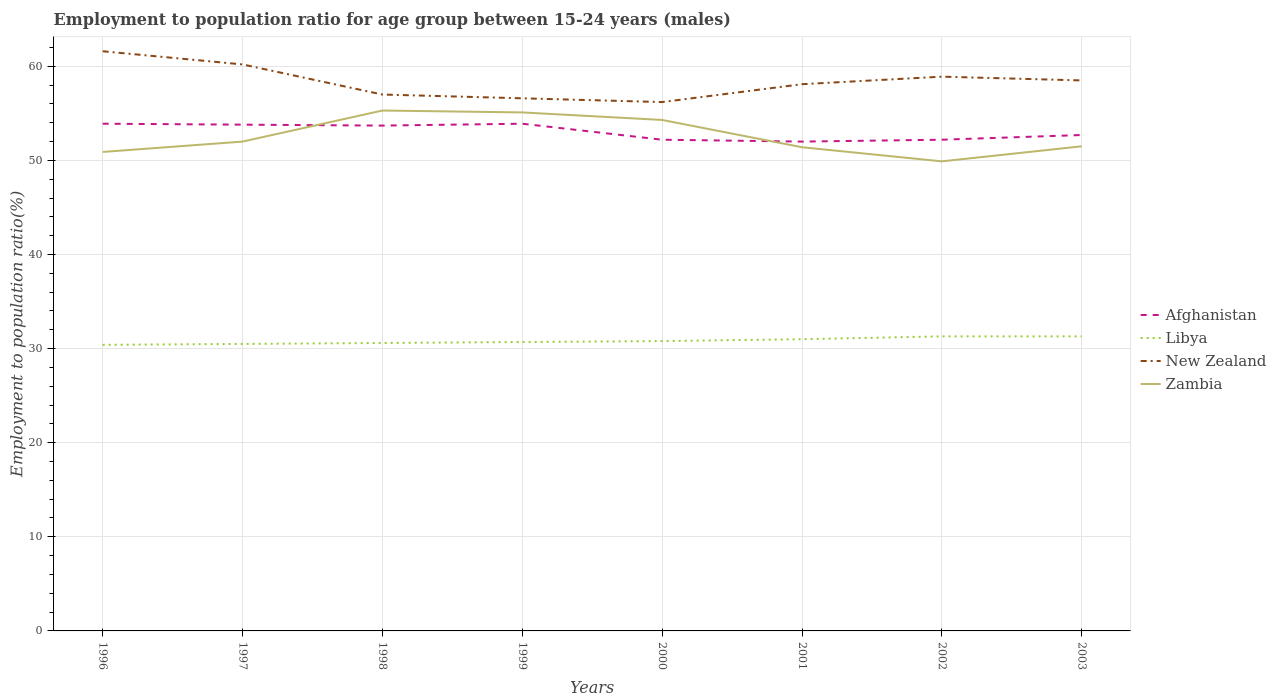How many different coloured lines are there?
Give a very brief answer. 4. Is the number of lines equal to the number of legend labels?
Give a very brief answer. Yes. Across all years, what is the maximum employment to population ratio in Afghanistan?
Provide a succinct answer. 52. What is the total employment to population ratio in Afghanistan in the graph?
Your response must be concise. -0.7. What is the difference between the highest and the second highest employment to population ratio in Afghanistan?
Offer a very short reply. 1.9. Are the values on the major ticks of Y-axis written in scientific E-notation?
Offer a terse response. No. Does the graph contain any zero values?
Provide a succinct answer. No. Where does the legend appear in the graph?
Provide a short and direct response. Center right. How are the legend labels stacked?
Your answer should be compact. Vertical. What is the title of the graph?
Ensure brevity in your answer.  Employment to population ratio for age group between 15-24 years (males). Does "Mexico" appear as one of the legend labels in the graph?
Your answer should be compact. No. What is the label or title of the X-axis?
Provide a short and direct response. Years. What is the label or title of the Y-axis?
Provide a succinct answer. Employment to population ratio(%). What is the Employment to population ratio(%) in Afghanistan in 1996?
Ensure brevity in your answer.  53.9. What is the Employment to population ratio(%) in Libya in 1996?
Ensure brevity in your answer.  30.4. What is the Employment to population ratio(%) of New Zealand in 1996?
Give a very brief answer. 61.6. What is the Employment to population ratio(%) of Zambia in 1996?
Ensure brevity in your answer.  50.9. What is the Employment to population ratio(%) of Afghanistan in 1997?
Keep it short and to the point. 53.8. What is the Employment to population ratio(%) of Libya in 1997?
Offer a very short reply. 30.5. What is the Employment to population ratio(%) in New Zealand in 1997?
Ensure brevity in your answer.  60.2. What is the Employment to population ratio(%) in Afghanistan in 1998?
Your answer should be very brief. 53.7. What is the Employment to population ratio(%) in Libya in 1998?
Keep it short and to the point. 30.6. What is the Employment to population ratio(%) in Zambia in 1998?
Keep it short and to the point. 55.3. What is the Employment to population ratio(%) in Afghanistan in 1999?
Offer a very short reply. 53.9. What is the Employment to population ratio(%) in Libya in 1999?
Provide a short and direct response. 30.7. What is the Employment to population ratio(%) in New Zealand in 1999?
Your answer should be compact. 56.6. What is the Employment to population ratio(%) of Zambia in 1999?
Your answer should be very brief. 55.1. What is the Employment to population ratio(%) in Afghanistan in 2000?
Ensure brevity in your answer.  52.2. What is the Employment to population ratio(%) in Libya in 2000?
Provide a short and direct response. 30.8. What is the Employment to population ratio(%) in New Zealand in 2000?
Offer a very short reply. 56.2. What is the Employment to population ratio(%) in Zambia in 2000?
Provide a succinct answer. 54.3. What is the Employment to population ratio(%) of Afghanistan in 2001?
Keep it short and to the point. 52. What is the Employment to population ratio(%) in Libya in 2001?
Keep it short and to the point. 31. What is the Employment to population ratio(%) in New Zealand in 2001?
Keep it short and to the point. 58.1. What is the Employment to population ratio(%) in Zambia in 2001?
Keep it short and to the point. 51.4. What is the Employment to population ratio(%) in Afghanistan in 2002?
Your response must be concise. 52.2. What is the Employment to population ratio(%) in Libya in 2002?
Offer a terse response. 31.3. What is the Employment to population ratio(%) in New Zealand in 2002?
Make the answer very short. 58.9. What is the Employment to population ratio(%) in Zambia in 2002?
Your answer should be compact. 49.9. What is the Employment to population ratio(%) of Afghanistan in 2003?
Keep it short and to the point. 52.7. What is the Employment to population ratio(%) of Libya in 2003?
Give a very brief answer. 31.3. What is the Employment to population ratio(%) of New Zealand in 2003?
Your answer should be very brief. 58.5. What is the Employment to population ratio(%) in Zambia in 2003?
Your response must be concise. 51.5. Across all years, what is the maximum Employment to population ratio(%) in Afghanistan?
Ensure brevity in your answer.  53.9. Across all years, what is the maximum Employment to population ratio(%) of Libya?
Your answer should be compact. 31.3. Across all years, what is the maximum Employment to population ratio(%) in New Zealand?
Your answer should be compact. 61.6. Across all years, what is the maximum Employment to population ratio(%) of Zambia?
Offer a terse response. 55.3. Across all years, what is the minimum Employment to population ratio(%) in Libya?
Your answer should be compact. 30.4. Across all years, what is the minimum Employment to population ratio(%) of New Zealand?
Offer a very short reply. 56.2. Across all years, what is the minimum Employment to population ratio(%) in Zambia?
Offer a terse response. 49.9. What is the total Employment to population ratio(%) in Afghanistan in the graph?
Make the answer very short. 424.4. What is the total Employment to population ratio(%) in Libya in the graph?
Give a very brief answer. 246.6. What is the total Employment to population ratio(%) of New Zealand in the graph?
Your response must be concise. 467.1. What is the total Employment to population ratio(%) of Zambia in the graph?
Provide a short and direct response. 420.4. What is the difference between the Employment to population ratio(%) in Zambia in 1996 and that in 1997?
Your answer should be compact. -1.1. What is the difference between the Employment to population ratio(%) of New Zealand in 1996 and that in 1999?
Offer a terse response. 5. What is the difference between the Employment to population ratio(%) of Zambia in 1996 and that in 1999?
Ensure brevity in your answer.  -4.2. What is the difference between the Employment to population ratio(%) in Libya in 1996 and that in 2000?
Provide a succinct answer. -0.4. What is the difference between the Employment to population ratio(%) in New Zealand in 1996 and that in 2000?
Your answer should be very brief. 5.4. What is the difference between the Employment to population ratio(%) of Zambia in 1996 and that in 2000?
Provide a succinct answer. -3.4. What is the difference between the Employment to population ratio(%) of Afghanistan in 1996 and that in 2001?
Offer a terse response. 1.9. What is the difference between the Employment to population ratio(%) in New Zealand in 1996 and that in 2001?
Make the answer very short. 3.5. What is the difference between the Employment to population ratio(%) in Libya in 1996 and that in 2002?
Your answer should be very brief. -0.9. What is the difference between the Employment to population ratio(%) in Zambia in 1996 and that in 2002?
Offer a very short reply. 1. What is the difference between the Employment to population ratio(%) in Zambia in 1996 and that in 2003?
Your response must be concise. -0.6. What is the difference between the Employment to population ratio(%) in Afghanistan in 1997 and that in 1999?
Your answer should be very brief. -0.1. What is the difference between the Employment to population ratio(%) of New Zealand in 1997 and that in 1999?
Provide a succinct answer. 3.6. What is the difference between the Employment to population ratio(%) in New Zealand in 1997 and that in 2000?
Your response must be concise. 4. What is the difference between the Employment to population ratio(%) of Afghanistan in 1997 and that in 2001?
Keep it short and to the point. 1.8. What is the difference between the Employment to population ratio(%) of Libya in 1997 and that in 2001?
Your answer should be very brief. -0.5. What is the difference between the Employment to population ratio(%) in New Zealand in 1997 and that in 2001?
Offer a terse response. 2.1. What is the difference between the Employment to population ratio(%) in Zambia in 1997 and that in 2001?
Your answer should be compact. 0.6. What is the difference between the Employment to population ratio(%) in Afghanistan in 1997 and that in 2002?
Offer a terse response. 1.6. What is the difference between the Employment to population ratio(%) of New Zealand in 1997 and that in 2002?
Your answer should be compact. 1.3. What is the difference between the Employment to population ratio(%) of Afghanistan in 1997 and that in 2003?
Provide a succinct answer. 1.1. What is the difference between the Employment to population ratio(%) in Zambia in 1997 and that in 2003?
Ensure brevity in your answer.  0.5. What is the difference between the Employment to population ratio(%) of New Zealand in 1998 and that in 1999?
Provide a succinct answer. 0.4. What is the difference between the Employment to population ratio(%) of Zambia in 1998 and that in 2000?
Provide a short and direct response. 1. What is the difference between the Employment to population ratio(%) in Libya in 1998 and that in 2001?
Provide a succinct answer. -0.4. What is the difference between the Employment to population ratio(%) of New Zealand in 1998 and that in 2001?
Your answer should be very brief. -1.1. What is the difference between the Employment to population ratio(%) of Zambia in 1998 and that in 2001?
Your response must be concise. 3.9. What is the difference between the Employment to population ratio(%) in Libya in 1998 and that in 2002?
Offer a very short reply. -0.7. What is the difference between the Employment to population ratio(%) of Zambia in 1998 and that in 2002?
Keep it short and to the point. 5.4. What is the difference between the Employment to population ratio(%) of Afghanistan in 1998 and that in 2003?
Provide a short and direct response. 1. What is the difference between the Employment to population ratio(%) in New Zealand in 1998 and that in 2003?
Ensure brevity in your answer.  -1.5. What is the difference between the Employment to population ratio(%) of Zambia in 1998 and that in 2003?
Provide a short and direct response. 3.8. What is the difference between the Employment to population ratio(%) in Afghanistan in 1999 and that in 2000?
Provide a short and direct response. 1.7. What is the difference between the Employment to population ratio(%) of Libya in 1999 and that in 2000?
Offer a terse response. -0.1. What is the difference between the Employment to population ratio(%) of New Zealand in 1999 and that in 2000?
Offer a terse response. 0.4. What is the difference between the Employment to population ratio(%) in Libya in 1999 and that in 2001?
Your answer should be compact. -0.3. What is the difference between the Employment to population ratio(%) of Zambia in 1999 and that in 2001?
Your answer should be very brief. 3.7. What is the difference between the Employment to population ratio(%) of New Zealand in 1999 and that in 2003?
Your answer should be compact. -1.9. What is the difference between the Employment to population ratio(%) in Libya in 2000 and that in 2001?
Provide a short and direct response. -0.2. What is the difference between the Employment to population ratio(%) of New Zealand in 2000 and that in 2001?
Give a very brief answer. -1.9. What is the difference between the Employment to population ratio(%) in Zambia in 2000 and that in 2001?
Offer a terse response. 2.9. What is the difference between the Employment to population ratio(%) of Libya in 2000 and that in 2002?
Provide a short and direct response. -0.5. What is the difference between the Employment to population ratio(%) in Zambia in 2000 and that in 2002?
Your response must be concise. 4.4. What is the difference between the Employment to population ratio(%) of Afghanistan in 2000 and that in 2003?
Your answer should be compact. -0.5. What is the difference between the Employment to population ratio(%) in Libya in 2000 and that in 2003?
Make the answer very short. -0.5. What is the difference between the Employment to population ratio(%) in New Zealand in 2000 and that in 2003?
Offer a terse response. -2.3. What is the difference between the Employment to population ratio(%) of Afghanistan in 2001 and that in 2002?
Provide a succinct answer. -0.2. What is the difference between the Employment to population ratio(%) of Libya in 2001 and that in 2002?
Keep it short and to the point. -0.3. What is the difference between the Employment to population ratio(%) of Afghanistan in 2001 and that in 2003?
Provide a succinct answer. -0.7. What is the difference between the Employment to population ratio(%) in New Zealand in 2001 and that in 2003?
Keep it short and to the point. -0.4. What is the difference between the Employment to population ratio(%) of Zambia in 2001 and that in 2003?
Make the answer very short. -0.1. What is the difference between the Employment to population ratio(%) of New Zealand in 2002 and that in 2003?
Your response must be concise. 0.4. What is the difference between the Employment to population ratio(%) of Zambia in 2002 and that in 2003?
Ensure brevity in your answer.  -1.6. What is the difference between the Employment to population ratio(%) of Afghanistan in 1996 and the Employment to population ratio(%) of Libya in 1997?
Provide a short and direct response. 23.4. What is the difference between the Employment to population ratio(%) of Afghanistan in 1996 and the Employment to population ratio(%) of Zambia in 1997?
Offer a terse response. 1.9. What is the difference between the Employment to population ratio(%) in Libya in 1996 and the Employment to population ratio(%) in New Zealand in 1997?
Ensure brevity in your answer.  -29.8. What is the difference between the Employment to population ratio(%) in Libya in 1996 and the Employment to population ratio(%) in Zambia in 1997?
Make the answer very short. -21.6. What is the difference between the Employment to population ratio(%) of Afghanistan in 1996 and the Employment to population ratio(%) of Libya in 1998?
Provide a short and direct response. 23.3. What is the difference between the Employment to population ratio(%) in Afghanistan in 1996 and the Employment to population ratio(%) in Zambia in 1998?
Offer a terse response. -1.4. What is the difference between the Employment to population ratio(%) in Libya in 1996 and the Employment to population ratio(%) in New Zealand in 1998?
Make the answer very short. -26.6. What is the difference between the Employment to population ratio(%) of Libya in 1996 and the Employment to population ratio(%) of Zambia in 1998?
Give a very brief answer. -24.9. What is the difference between the Employment to population ratio(%) in New Zealand in 1996 and the Employment to population ratio(%) in Zambia in 1998?
Offer a very short reply. 6.3. What is the difference between the Employment to population ratio(%) of Afghanistan in 1996 and the Employment to population ratio(%) of Libya in 1999?
Your answer should be compact. 23.2. What is the difference between the Employment to population ratio(%) of Afghanistan in 1996 and the Employment to population ratio(%) of New Zealand in 1999?
Offer a very short reply. -2.7. What is the difference between the Employment to population ratio(%) in Libya in 1996 and the Employment to population ratio(%) in New Zealand in 1999?
Offer a very short reply. -26.2. What is the difference between the Employment to population ratio(%) of Libya in 1996 and the Employment to population ratio(%) of Zambia in 1999?
Provide a short and direct response. -24.7. What is the difference between the Employment to population ratio(%) in New Zealand in 1996 and the Employment to population ratio(%) in Zambia in 1999?
Make the answer very short. 6.5. What is the difference between the Employment to population ratio(%) in Afghanistan in 1996 and the Employment to population ratio(%) in Libya in 2000?
Provide a short and direct response. 23.1. What is the difference between the Employment to population ratio(%) in Afghanistan in 1996 and the Employment to population ratio(%) in New Zealand in 2000?
Offer a terse response. -2.3. What is the difference between the Employment to population ratio(%) of Libya in 1996 and the Employment to population ratio(%) of New Zealand in 2000?
Your answer should be very brief. -25.8. What is the difference between the Employment to population ratio(%) of Libya in 1996 and the Employment to population ratio(%) of Zambia in 2000?
Your response must be concise. -23.9. What is the difference between the Employment to population ratio(%) of New Zealand in 1996 and the Employment to population ratio(%) of Zambia in 2000?
Offer a terse response. 7.3. What is the difference between the Employment to population ratio(%) of Afghanistan in 1996 and the Employment to population ratio(%) of Libya in 2001?
Provide a succinct answer. 22.9. What is the difference between the Employment to population ratio(%) of Afghanistan in 1996 and the Employment to population ratio(%) of Zambia in 2001?
Give a very brief answer. 2.5. What is the difference between the Employment to population ratio(%) of Libya in 1996 and the Employment to population ratio(%) of New Zealand in 2001?
Ensure brevity in your answer.  -27.7. What is the difference between the Employment to population ratio(%) of Libya in 1996 and the Employment to population ratio(%) of Zambia in 2001?
Provide a short and direct response. -21. What is the difference between the Employment to population ratio(%) in New Zealand in 1996 and the Employment to population ratio(%) in Zambia in 2001?
Your answer should be compact. 10.2. What is the difference between the Employment to population ratio(%) of Afghanistan in 1996 and the Employment to population ratio(%) of Libya in 2002?
Give a very brief answer. 22.6. What is the difference between the Employment to population ratio(%) of Afghanistan in 1996 and the Employment to population ratio(%) of New Zealand in 2002?
Offer a terse response. -5. What is the difference between the Employment to population ratio(%) of Afghanistan in 1996 and the Employment to population ratio(%) of Zambia in 2002?
Keep it short and to the point. 4. What is the difference between the Employment to population ratio(%) in Libya in 1996 and the Employment to population ratio(%) in New Zealand in 2002?
Your answer should be compact. -28.5. What is the difference between the Employment to population ratio(%) in Libya in 1996 and the Employment to population ratio(%) in Zambia in 2002?
Your answer should be compact. -19.5. What is the difference between the Employment to population ratio(%) of New Zealand in 1996 and the Employment to population ratio(%) of Zambia in 2002?
Ensure brevity in your answer.  11.7. What is the difference between the Employment to population ratio(%) of Afghanistan in 1996 and the Employment to population ratio(%) of Libya in 2003?
Give a very brief answer. 22.6. What is the difference between the Employment to population ratio(%) of Afghanistan in 1996 and the Employment to population ratio(%) of New Zealand in 2003?
Your answer should be compact. -4.6. What is the difference between the Employment to population ratio(%) in Afghanistan in 1996 and the Employment to population ratio(%) in Zambia in 2003?
Provide a short and direct response. 2.4. What is the difference between the Employment to population ratio(%) of Libya in 1996 and the Employment to population ratio(%) of New Zealand in 2003?
Provide a succinct answer. -28.1. What is the difference between the Employment to population ratio(%) in Libya in 1996 and the Employment to population ratio(%) in Zambia in 2003?
Provide a succinct answer. -21.1. What is the difference between the Employment to population ratio(%) of Afghanistan in 1997 and the Employment to population ratio(%) of Libya in 1998?
Your answer should be very brief. 23.2. What is the difference between the Employment to population ratio(%) of Afghanistan in 1997 and the Employment to population ratio(%) of New Zealand in 1998?
Ensure brevity in your answer.  -3.2. What is the difference between the Employment to population ratio(%) of Afghanistan in 1997 and the Employment to population ratio(%) of Zambia in 1998?
Offer a very short reply. -1.5. What is the difference between the Employment to population ratio(%) of Libya in 1997 and the Employment to population ratio(%) of New Zealand in 1998?
Your answer should be compact. -26.5. What is the difference between the Employment to population ratio(%) of Libya in 1997 and the Employment to population ratio(%) of Zambia in 1998?
Your response must be concise. -24.8. What is the difference between the Employment to population ratio(%) in New Zealand in 1997 and the Employment to population ratio(%) in Zambia in 1998?
Keep it short and to the point. 4.9. What is the difference between the Employment to population ratio(%) in Afghanistan in 1997 and the Employment to population ratio(%) in Libya in 1999?
Give a very brief answer. 23.1. What is the difference between the Employment to population ratio(%) in Afghanistan in 1997 and the Employment to population ratio(%) in New Zealand in 1999?
Offer a very short reply. -2.8. What is the difference between the Employment to population ratio(%) of Libya in 1997 and the Employment to population ratio(%) of New Zealand in 1999?
Your answer should be compact. -26.1. What is the difference between the Employment to population ratio(%) of Libya in 1997 and the Employment to population ratio(%) of Zambia in 1999?
Provide a short and direct response. -24.6. What is the difference between the Employment to population ratio(%) in New Zealand in 1997 and the Employment to population ratio(%) in Zambia in 1999?
Your answer should be very brief. 5.1. What is the difference between the Employment to population ratio(%) in Afghanistan in 1997 and the Employment to population ratio(%) in New Zealand in 2000?
Make the answer very short. -2.4. What is the difference between the Employment to population ratio(%) of Libya in 1997 and the Employment to population ratio(%) of New Zealand in 2000?
Ensure brevity in your answer.  -25.7. What is the difference between the Employment to population ratio(%) in Libya in 1997 and the Employment to population ratio(%) in Zambia in 2000?
Your answer should be very brief. -23.8. What is the difference between the Employment to population ratio(%) in Afghanistan in 1997 and the Employment to population ratio(%) in Libya in 2001?
Offer a very short reply. 22.8. What is the difference between the Employment to population ratio(%) of Afghanistan in 1997 and the Employment to population ratio(%) of New Zealand in 2001?
Your answer should be very brief. -4.3. What is the difference between the Employment to population ratio(%) in Afghanistan in 1997 and the Employment to population ratio(%) in Zambia in 2001?
Keep it short and to the point. 2.4. What is the difference between the Employment to population ratio(%) of Libya in 1997 and the Employment to population ratio(%) of New Zealand in 2001?
Make the answer very short. -27.6. What is the difference between the Employment to population ratio(%) of Libya in 1997 and the Employment to population ratio(%) of Zambia in 2001?
Your answer should be compact. -20.9. What is the difference between the Employment to population ratio(%) in New Zealand in 1997 and the Employment to population ratio(%) in Zambia in 2001?
Keep it short and to the point. 8.8. What is the difference between the Employment to population ratio(%) of Afghanistan in 1997 and the Employment to population ratio(%) of New Zealand in 2002?
Provide a succinct answer. -5.1. What is the difference between the Employment to population ratio(%) in Libya in 1997 and the Employment to population ratio(%) in New Zealand in 2002?
Give a very brief answer. -28.4. What is the difference between the Employment to population ratio(%) in Libya in 1997 and the Employment to population ratio(%) in Zambia in 2002?
Your answer should be compact. -19.4. What is the difference between the Employment to population ratio(%) in New Zealand in 1997 and the Employment to population ratio(%) in Zambia in 2002?
Offer a very short reply. 10.3. What is the difference between the Employment to population ratio(%) in Afghanistan in 1997 and the Employment to population ratio(%) in Libya in 2003?
Ensure brevity in your answer.  22.5. What is the difference between the Employment to population ratio(%) in New Zealand in 1997 and the Employment to population ratio(%) in Zambia in 2003?
Your response must be concise. 8.7. What is the difference between the Employment to population ratio(%) in Afghanistan in 1998 and the Employment to population ratio(%) in New Zealand in 1999?
Offer a terse response. -2.9. What is the difference between the Employment to population ratio(%) of Libya in 1998 and the Employment to population ratio(%) of New Zealand in 1999?
Give a very brief answer. -26. What is the difference between the Employment to population ratio(%) in Libya in 1998 and the Employment to population ratio(%) in Zambia in 1999?
Your answer should be very brief. -24.5. What is the difference between the Employment to population ratio(%) of New Zealand in 1998 and the Employment to population ratio(%) of Zambia in 1999?
Give a very brief answer. 1.9. What is the difference between the Employment to population ratio(%) in Afghanistan in 1998 and the Employment to population ratio(%) in Libya in 2000?
Offer a very short reply. 22.9. What is the difference between the Employment to population ratio(%) in Afghanistan in 1998 and the Employment to population ratio(%) in New Zealand in 2000?
Ensure brevity in your answer.  -2.5. What is the difference between the Employment to population ratio(%) in Afghanistan in 1998 and the Employment to population ratio(%) in Zambia in 2000?
Ensure brevity in your answer.  -0.6. What is the difference between the Employment to population ratio(%) in Libya in 1998 and the Employment to population ratio(%) in New Zealand in 2000?
Your response must be concise. -25.6. What is the difference between the Employment to population ratio(%) in Libya in 1998 and the Employment to population ratio(%) in Zambia in 2000?
Offer a terse response. -23.7. What is the difference between the Employment to population ratio(%) in Afghanistan in 1998 and the Employment to population ratio(%) in Libya in 2001?
Your answer should be very brief. 22.7. What is the difference between the Employment to population ratio(%) of Afghanistan in 1998 and the Employment to population ratio(%) of Zambia in 2001?
Provide a succinct answer. 2.3. What is the difference between the Employment to population ratio(%) of Libya in 1998 and the Employment to population ratio(%) of New Zealand in 2001?
Offer a terse response. -27.5. What is the difference between the Employment to population ratio(%) in Libya in 1998 and the Employment to population ratio(%) in Zambia in 2001?
Ensure brevity in your answer.  -20.8. What is the difference between the Employment to population ratio(%) of Afghanistan in 1998 and the Employment to population ratio(%) of Libya in 2002?
Your answer should be compact. 22.4. What is the difference between the Employment to population ratio(%) of Afghanistan in 1998 and the Employment to population ratio(%) of New Zealand in 2002?
Your answer should be compact. -5.2. What is the difference between the Employment to population ratio(%) in Afghanistan in 1998 and the Employment to population ratio(%) in Zambia in 2002?
Make the answer very short. 3.8. What is the difference between the Employment to population ratio(%) of Libya in 1998 and the Employment to population ratio(%) of New Zealand in 2002?
Keep it short and to the point. -28.3. What is the difference between the Employment to population ratio(%) in Libya in 1998 and the Employment to population ratio(%) in Zambia in 2002?
Offer a terse response. -19.3. What is the difference between the Employment to population ratio(%) of New Zealand in 1998 and the Employment to population ratio(%) of Zambia in 2002?
Your response must be concise. 7.1. What is the difference between the Employment to population ratio(%) in Afghanistan in 1998 and the Employment to population ratio(%) in Libya in 2003?
Make the answer very short. 22.4. What is the difference between the Employment to population ratio(%) of Afghanistan in 1998 and the Employment to population ratio(%) of New Zealand in 2003?
Your response must be concise. -4.8. What is the difference between the Employment to population ratio(%) of Afghanistan in 1998 and the Employment to population ratio(%) of Zambia in 2003?
Your answer should be compact. 2.2. What is the difference between the Employment to population ratio(%) in Libya in 1998 and the Employment to population ratio(%) in New Zealand in 2003?
Your answer should be compact. -27.9. What is the difference between the Employment to population ratio(%) in Libya in 1998 and the Employment to population ratio(%) in Zambia in 2003?
Your answer should be very brief. -20.9. What is the difference between the Employment to population ratio(%) in New Zealand in 1998 and the Employment to population ratio(%) in Zambia in 2003?
Your answer should be compact. 5.5. What is the difference between the Employment to population ratio(%) of Afghanistan in 1999 and the Employment to population ratio(%) of Libya in 2000?
Give a very brief answer. 23.1. What is the difference between the Employment to population ratio(%) in Afghanistan in 1999 and the Employment to population ratio(%) in Zambia in 2000?
Offer a terse response. -0.4. What is the difference between the Employment to population ratio(%) of Libya in 1999 and the Employment to population ratio(%) of New Zealand in 2000?
Make the answer very short. -25.5. What is the difference between the Employment to population ratio(%) of Libya in 1999 and the Employment to population ratio(%) of Zambia in 2000?
Make the answer very short. -23.6. What is the difference between the Employment to population ratio(%) in New Zealand in 1999 and the Employment to population ratio(%) in Zambia in 2000?
Make the answer very short. 2.3. What is the difference between the Employment to population ratio(%) in Afghanistan in 1999 and the Employment to population ratio(%) in Libya in 2001?
Give a very brief answer. 22.9. What is the difference between the Employment to population ratio(%) of Libya in 1999 and the Employment to population ratio(%) of New Zealand in 2001?
Offer a very short reply. -27.4. What is the difference between the Employment to population ratio(%) of Libya in 1999 and the Employment to population ratio(%) of Zambia in 2001?
Provide a short and direct response. -20.7. What is the difference between the Employment to population ratio(%) of New Zealand in 1999 and the Employment to population ratio(%) of Zambia in 2001?
Your answer should be compact. 5.2. What is the difference between the Employment to population ratio(%) in Afghanistan in 1999 and the Employment to population ratio(%) in Libya in 2002?
Offer a terse response. 22.6. What is the difference between the Employment to population ratio(%) of Afghanistan in 1999 and the Employment to population ratio(%) of New Zealand in 2002?
Offer a very short reply. -5. What is the difference between the Employment to population ratio(%) of Libya in 1999 and the Employment to population ratio(%) of New Zealand in 2002?
Keep it short and to the point. -28.2. What is the difference between the Employment to population ratio(%) in Libya in 1999 and the Employment to population ratio(%) in Zambia in 2002?
Your response must be concise. -19.2. What is the difference between the Employment to population ratio(%) of New Zealand in 1999 and the Employment to population ratio(%) of Zambia in 2002?
Offer a terse response. 6.7. What is the difference between the Employment to population ratio(%) in Afghanistan in 1999 and the Employment to population ratio(%) in Libya in 2003?
Offer a terse response. 22.6. What is the difference between the Employment to population ratio(%) of Afghanistan in 1999 and the Employment to population ratio(%) of New Zealand in 2003?
Give a very brief answer. -4.6. What is the difference between the Employment to population ratio(%) of Afghanistan in 1999 and the Employment to population ratio(%) of Zambia in 2003?
Offer a terse response. 2.4. What is the difference between the Employment to population ratio(%) of Libya in 1999 and the Employment to population ratio(%) of New Zealand in 2003?
Ensure brevity in your answer.  -27.8. What is the difference between the Employment to population ratio(%) in Libya in 1999 and the Employment to population ratio(%) in Zambia in 2003?
Make the answer very short. -20.8. What is the difference between the Employment to population ratio(%) of Afghanistan in 2000 and the Employment to population ratio(%) of Libya in 2001?
Make the answer very short. 21.2. What is the difference between the Employment to population ratio(%) in Libya in 2000 and the Employment to population ratio(%) in New Zealand in 2001?
Your answer should be compact. -27.3. What is the difference between the Employment to population ratio(%) in Libya in 2000 and the Employment to population ratio(%) in Zambia in 2001?
Your response must be concise. -20.6. What is the difference between the Employment to population ratio(%) of New Zealand in 2000 and the Employment to population ratio(%) of Zambia in 2001?
Ensure brevity in your answer.  4.8. What is the difference between the Employment to population ratio(%) in Afghanistan in 2000 and the Employment to population ratio(%) in Libya in 2002?
Give a very brief answer. 20.9. What is the difference between the Employment to population ratio(%) of Afghanistan in 2000 and the Employment to population ratio(%) of New Zealand in 2002?
Make the answer very short. -6.7. What is the difference between the Employment to population ratio(%) of Afghanistan in 2000 and the Employment to population ratio(%) of Zambia in 2002?
Ensure brevity in your answer.  2.3. What is the difference between the Employment to population ratio(%) of Libya in 2000 and the Employment to population ratio(%) of New Zealand in 2002?
Give a very brief answer. -28.1. What is the difference between the Employment to population ratio(%) in Libya in 2000 and the Employment to population ratio(%) in Zambia in 2002?
Offer a very short reply. -19.1. What is the difference between the Employment to population ratio(%) in Afghanistan in 2000 and the Employment to population ratio(%) in Libya in 2003?
Offer a very short reply. 20.9. What is the difference between the Employment to population ratio(%) of Libya in 2000 and the Employment to population ratio(%) of New Zealand in 2003?
Your answer should be compact. -27.7. What is the difference between the Employment to population ratio(%) of Libya in 2000 and the Employment to population ratio(%) of Zambia in 2003?
Provide a succinct answer. -20.7. What is the difference between the Employment to population ratio(%) in Afghanistan in 2001 and the Employment to population ratio(%) in Libya in 2002?
Your answer should be compact. 20.7. What is the difference between the Employment to population ratio(%) of Afghanistan in 2001 and the Employment to population ratio(%) of New Zealand in 2002?
Provide a succinct answer. -6.9. What is the difference between the Employment to population ratio(%) in Libya in 2001 and the Employment to population ratio(%) in New Zealand in 2002?
Your response must be concise. -27.9. What is the difference between the Employment to population ratio(%) of Libya in 2001 and the Employment to population ratio(%) of Zambia in 2002?
Give a very brief answer. -18.9. What is the difference between the Employment to population ratio(%) in Afghanistan in 2001 and the Employment to population ratio(%) in Libya in 2003?
Keep it short and to the point. 20.7. What is the difference between the Employment to population ratio(%) in Afghanistan in 2001 and the Employment to population ratio(%) in New Zealand in 2003?
Make the answer very short. -6.5. What is the difference between the Employment to population ratio(%) of Libya in 2001 and the Employment to population ratio(%) of New Zealand in 2003?
Provide a short and direct response. -27.5. What is the difference between the Employment to population ratio(%) of Libya in 2001 and the Employment to population ratio(%) of Zambia in 2003?
Give a very brief answer. -20.5. What is the difference between the Employment to population ratio(%) of Afghanistan in 2002 and the Employment to population ratio(%) of Libya in 2003?
Your answer should be very brief. 20.9. What is the difference between the Employment to population ratio(%) of Libya in 2002 and the Employment to population ratio(%) of New Zealand in 2003?
Give a very brief answer. -27.2. What is the difference between the Employment to population ratio(%) of Libya in 2002 and the Employment to population ratio(%) of Zambia in 2003?
Provide a short and direct response. -20.2. What is the difference between the Employment to population ratio(%) in New Zealand in 2002 and the Employment to population ratio(%) in Zambia in 2003?
Offer a terse response. 7.4. What is the average Employment to population ratio(%) in Afghanistan per year?
Your response must be concise. 53.05. What is the average Employment to population ratio(%) in Libya per year?
Make the answer very short. 30.82. What is the average Employment to population ratio(%) in New Zealand per year?
Keep it short and to the point. 58.39. What is the average Employment to population ratio(%) of Zambia per year?
Your response must be concise. 52.55. In the year 1996, what is the difference between the Employment to population ratio(%) in Afghanistan and Employment to population ratio(%) in Libya?
Your response must be concise. 23.5. In the year 1996, what is the difference between the Employment to population ratio(%) in Afghanistan and Employment to population ratio(%) in New Zealand?
Provide a succinct answer. -7.7. In the year 1996, what is the difference between the Employment to population ratio(%) in Libya and Employment to population ratio(%) in New Zealand?
Keep it short and to the point. -31.2. In the year 1996, what is the difference between the Employment to population ratio(%) of Libya and Employment to population ratio(%) of Zambia?
Your response must be concise. -20.5. In the year 1996, what is the difference between the Employment to population ratio(%) in New Zealand and Employment to population ratio(%) in Zambia?
Provide a short and direct response. 10.7. In the year 1997, what is the difference between the Employment to population ratio(%) of Afghanistan and Employment to population ratio(%) of Libya?
Your answer should be very brief. 23.3. In the year 1997, what is the difference between the Employment to population ratio(%) of Afghanistan and Employment to population ratio(%) of New Zealand?
Make the answer very short. -6.4. In the year 1997, what is the difference between the Employment to population ratio(%) of Libya and Employment to population ratio(%) of New Zealand?
Your answer should be compact. -29.7. In the year 1997, what is the difference between the Employment to population ratio(%) of Libya and Employment to population ratio(%) of Zambia?
Your answer should be very brief. -21.5. In the year 1997, what is the difference between the Employment to population ratio(%) in New Zealand and Employment to population ratio(%) in Zambia?
Keep it short and to the point. 8.2. In the year 1998, what is the difference between the Employment to population ratio(%) of Afghanistan and Employment to population ratio(%) of Libya?
Provide a succinct answer. 23.1. In the year 1998, what is the difference between the Employment to population ratio(%) in Afghanistan and Employment to population ratio(%) in New Zealand?
Provide a short and direct response. -3.3. In the year 1998, what is the difference between the Employment to population ratio(%) of Libya and Employment to population ratio(%) of New Zealand?
Provide a succinct answer. -26.4. In the year 1998, what is the difference between the Employment to population ratio(%) of Libya and Employment to population ratio(%) of Zambia?
Make the answer very short. -24.7. In the year 1999, what is the difference between the Employment to population ratio(%) in Afghanistan and Employment to population ratio(%) in Libya?
Provide a succinct answer. 23.2. In the year 1999, what is the difference between the Employment to population ratio(%) of Afghanistan and Employment to population ratio(%) of New Zealand?
Your answer should be compact. -2.7. In the year 1999, what is the difference between the Employment to population ratio(%) in Libya and Employment to population ratio(%) in New Zealand?
Your response must be concise. -25.9. In the year 1999, what is the difference between the Employment to population ratio(%) of Libya and Employment to population ratio(%) of Zambia?
Your answer should be compact. -24.4. In the year 2000, what is the difference between the Employment to population ratio(%) in Afghanistan and Employment to population ratio(%) in Libya?
Provide a short and direct response. 21.4. In the year 2000, what is the difference between the Employment to population ratio(%) of Libya and Employment to population ratio(%) of New Zealand?
Your answer should be compact. -25.4. In the year 2000, what is the difference between the Employment to population ratio(%) of Libya and Employment to population ratio(%) of Zambia?
Offer a terse response. -23.5. In the year 2001, what is the difference between the Employment to population ratio(%) of Afghanistan and Employment to population ratio(%) of New Zealand?
Your response must be concise. -6.1. In the year 2001, what is the difference between the Employment to population ratio(%) in Afghanistan and Employment to population ratio(%) in Zambia?
Give a very brief answer. 0.6. In the year 2001, what is the difference between the Employment to population ratio(%) in Libya and Employment to population ratio(%) in New Zealand?
Give a very brief answer. -27.1. In the year 2001, what is the difference between the Employment to population ratio(%) of Libya and Employment to population ratio(%) of Zambia?
Offer a very short reply. -20.4. In the year 2001, what is the difference between the Employment to population ratio(%) of New Zealand and Employment to population ratio(%) of Zambia?
Your response must be concise. 6.7. In the year 2002, what is the difference between the Employment to population ratio(%) in Afghanistan and Employment to population ratio(%) in Libya?
Offer a terse response. 20.9. In the year 2002, what is the difference between the Employment to population ratio(%) in Afghanistan and Employment to population ratio(%) in New Zealand?
Offer a terse response. -6.7. In the year 2002, what is the difference between the Employment to population ratio(%) of Libya and Employment to population ratio(%) of New Zealand?
Your response must be concise. -27.6. In the year 2002, what is the difference between the Employment to population ratio(%) of Libya and Employment to population ratio(%) of Zambia?
Your answer should be very brief. -18.6. In the year 2003, what is the difference between the Employment to population ratio(%) in Afghanistan and Employment to population ratio(%) in Libya?
Provide a succinct answer. 21.4. In the year 2003, what is the difference between the Employment to population ratio(%) of Afghanistan and Employment to population ratio(%) of New Zealand?
Offer a very short reply. -5.8. In the year 2003, what is the difference between the Employment to population ratio(%) of Libya and Employment to population ratio(%) of New Zealand?
Keep it short and to the point. -27.2. In the year 2003, what is the difference between the Employment to population ratio(%) of Libya and Employment to population ratio(%) of Zambia?
Your answer should be compact. -20.2. In the year 2003, what is the difference between the Employment to population ratio(%) of New Zealand and Employment to population ratio(%) of Zambia?
Provide a short and direct response. 7. What is the ratio of the Employment to population ratio(%) of Libya in 1996 to that in 1997?
Your response must be concise. 1. What is the ratio of the Employment to population ratio(%) in New Zealand in 1996 to that in 1997?
Your answer should be very brief. 1.02. What is the ratio of the Employment to population ratio(%) in Zambia in 1996 to that in 1997?
Your response must be concise. 0.98. What is the ratio of the Employment to population ratio(%) of Afghanistan in 1996 to that in 1998?
Your answer should be compact. 1. What is the ratio of the Employment to population ratio(%) of New Zealand in 1996 to that in 1998?
Ensure brevity in your answer.  1.08. What is the ratio of the Employment to population ratio(%) of Zambia in 1996 to that in 1998?
Offer a very short reply. 0.92. What is the ratio of the Employment to population ratio(%) in Afghanistan in 1996 to that in 1999?
Your answer should be very brief. 1. What is the ratio of the Employment to population ratio(%) of Libya in 1996 to that in 1999?
Your answer should be very brief. 0.99. What is the ratio of the Employment to population ratio(%) of New Zealand in 1996 to that in 1999?
Ensure brevity in your answer.  1.09. What is the ratio of the Employment to population ratio(%) in Zambia in 1996 to that in 1999?
Ensure brevity in your answer.  0.92. What is the ratio of the Employment to population ratio(%) of Afghanistan in 1996 to that in 2000?
Give a very brief answer. 1.03. What is the ratio of the Employment to population ratio(%) in New Zealand in 1996 to that in 2000?
Keep it short and to the point. 1.1. What is the ratio of the Employment to population ratio(%) in Zambia in 1996 to that in 2000?
Provide a succinct answer. 0.94. What is the ratio of the Employment to population ratio(%) in Afghanistan in 1996 to that in 2001?
Your answer should be very brief. 1.04. What is the ratio of the Employment to population ratio(%) in Libya in 1996 to that in 2001?
Provide a succinct answer. 0.98. What is the ratio of the Employment to population ratio(%) in New Zealand in 1996 to that in 2001?
Offer a very short reply. 1.06. What is the ratio of the Employment to population ratio(%) in Zambia in 1996 to that in 2001?
Provide a succinct answer. 0.99. What is the ratio of the Employment to population ratio(%) of Afghanistan in 1996 to that in 2002?
Provide a short and direct response. 1.03. What is the ratio of the Employment to population ratio(%) of Libya in 1996 to that in 2002?
Offer a very short reply. 0.97. What is the ratio of the Employment to population ratio(%) in New Zealand in 1996 to that in 2002?
Your response must be concise. 1.05. What is the ratio of the Employment to population ratio(%) in Afghanistan in 1996 to that in 2003?
Offer a terse response. 1.02. What is the ratio of the Employment to population ratio(%) in Libya in 1996 to that in 2003?
Offer a terse response. 0.97. What is the ratio of the Employment to population ratio(%) in New Zealand in 1996 to that in 2003?
Provide a short and direct response. 1.05. What is the ratio of the Employment to population ratio(%) of Zambia in 1996 to that in 2003?
Ensure brevity in your answer.  0.99. What is the ratio of the Employment to population ratio(%) of Libya in 1997 to that in 1998?
Provide a succinct answer. 1. What is the ratio of the Employment to population ratio(%) of New Zealand in 1997 to that in 1998?
Ensure brevity in your answer.  1.06. What is the ratio of the Employment to population ratio(%) in Zambia in 1997 to that in 1998?
Make the answer very short. 0.94. What is the ratio of the Employment to population ratio(%) of Afghanistan in 1997 to that in 1999?
Your response must be concise. 1. What is the ratio of the Employment to population ratio(%) in Libya in 1997 to that in 1999?
Make the answer very short. 0.99. What is the ratio of the Employment to population ratio(%) of New Zealand in 1997 to that in 1999?
Give a very brief answer. 1.06. What is the ratio of the Employment to population ratio(%) of Zambia in 1997 to that in 1999?
Your response must be concise. 0.94. What is the ratio of the Employment to population ratio(%) in Afghanistan in 1997 to that in 2000?
Provide a succinct answer. 1.03. What is the ratio of the Employment to population ratio(%) of Libya in 1997 to that in 2000?
Your answer should be compact. 0.99. What is the ratio of the Employment to population ratio(%) of New Zealand in 1997 to that in 2000?
Provide a succinct answer. 1.07. What is the ratio of the Employment to population ratio(%) in Zambia in 1997 to that in 2000?
Your answer should be compact. 0.96. What is the ratio of the Employment to population ratio(%) of Afghanistan in 1997 to that in 2001?
Give a very brief answer. 1.03. What is the ratio of the Employment to population ratio(%) of Libya in 1997 to that in 2001?
Your answer should be very brief. 0.98. What is the ratio of the Employment to population ratio(%) of New Zealand in 1997 to that in 2001?
Provide a short and direct response. 1.04. What is the ratio of the Employment to population ratio(%) in Zambia in 1997 to that in 2001?
Your answer should be very brief. 1.01. What is the ratio of the Employment to population ratio(%) of Afghanistan in 1997 to that in 2002?
Offer a very short reply. 1.03. What is the ratio of the Employment to population ratio(%) in Libya in 1997 to that in 2002?
Give a very brief answer. 0.97. What is the ratio of the Employment to population ratio(%) of New Zealand in 1997 to that in 2002?
Offer a terse response. 1.02. What is the ratio of the Employment to population ratio(%) of Zambia in 1997 to that in 2002?
Your response must be concise. 1.04. What is the ratio of the Employment to population ratio(%) in Afghanistan in 1997 to that in 2003?
Give a very brief answer. 1.02. What is the ratio of the Employment to population ratio(%) of Libya in 1997 to that in 2003?
Offer a very short reply. 0.97. What is the ratio of the Employment to population ratio(%) in New Zealand in 1997 to that in 2003?
Ensure brevity in your answer.  1.03. What is the ratio of the Employment to population ratio(%) of Zambia in 1997 to that in 2003?
Offer a terse response. 1.01. What is the ratio of the Employment to population ratio(%) in Afghanistan in 1998 to that in 1999?
Provide a short and direct response. 1. What is the ratio of the Employment to population ratio(%) of Libya in 1998 to that in 1999?
Provide a succinct answer. 1. What is the ratio of the Employment to population ratio(%) in New Zealand in 1998 to that in 1999?
Offer a terse response. 1.01. What is the ratio of the Employment to population ratio(%) of Zambia in 1998 to that in 1999?
Keep it short and to the point. 1. What is the ratio of the Employment to population ratio(%) in Afghanistan in 1998 to that in 2000?
Provide a short and direct response. 1.03. What is the ratio of the Employment to population ratio(%) in Libya in 1998 to that in 2000?
Provide a short and direct response. 0.99. What is the ratio of the Employment to population ratio(%) in New Zealand in 1998 to that in 2000?
Give a very brief answer. 1.01. What is the ratio of the Employment to population ratio(%) in Zambia in 1998 to that in 2000?
Your response must be concise. 1.02. What is the ratio of the Employment to population ratio(%) in Afghanistan in 1998 to that in 2001?
Provide a succinct answer. 1.03. What is the ratio of the Employment to population ratio(%) of Libya in 1998 to that in 2001?
Provide a short and direct response. 0.99. What is the ratio of the Employment to population ratio(%) in New Zealand in 1998 to that in 2001?
Keep it short and to the point. 0.98. What is the ratio of the Employment to population ratio(%) in Zambia in 1998 to that in 2001?
Keep it short and to the point. 1.08. What is the ratio of the Employment to population ratio(%) of Afghanistan in 1998 to that in 2002?
Your answer should be compact. 1.03. What is the ratio of the Employment to population ratio(%) of Libya in 1998 to that in 2002?
Provide a succinct answer. 0.98. What is the ratio of the Employment to population ratio(%) in Zambia in 1998 to that in 2002?
Make the answer very short. 1.11. What is the ratio of the Employment to population ratio(%) of Libya in 1998 to that in 2003?
Provide a succinct answer. 0.98. What is the ratio of the Employment to population ratio(%) in New Zealand in 1998 to that in 2003?
Offer a terse response. 0.97. What is the ratio of the Employment to population ratio(%) in Zambia in 1998 to that in 2003?
Ensure brevity in your answer.  1.07. What is the ratio of the Employment to population ratio(%) of Afghanistan in 1999 to that in 2000?
Offer a very short reply. 1.03. What is the ratio of the Employment to population ratio(%) of Libya in 1999 to that in 2000?
Offer a terse response. 1. What is the ratio of the Employment to population ratio(%) in New Zealand in 1999 to that in 2000?
Make the answer very short. 1.01. What is the ratio of the Employment to population ratio(%) in Zambia in 1999 to that in 2000?
Offer a very short reply. 1.01. What is the ratio of the Employment to population ratio(%) of Afghanistan in 1999 to that in 2001?
Ensure brevity in your answer.  1.04. What is the ratio of the Employment to population ratio(%) of Libya in 1999 to that in 2001?
Provide a short and direct response. 0.99. What is the ratio of the Employment to population ratio(%) in New Zealand in 1999 to that in 2001?
Ensure brevity in your answer.  0.97. What is the ratio of the Employment to population ratio(%) of Zambia in 1999 to that in 2001?
Make the answer very short. 1.07. What is the ratio of the Employment to population ratio(%) of Afghanistan in 1999 to that in 2002?
Offer a very short reply. 1.03. What is the ratio of the Employment to population ratio(%) of Libya in 1999 to that in 2002?
Offer a very short reply. 0.98. What is the ratio of the Employment to population ratio(%) of Zambia in 1999 to that in 2002?
Provide a succinct answer. 1.1. What is the ratio of the Employment to population ratio(%) of Afghanistan in 1999 to that in 2003?
Keep it short and to the point. 1.02. What is the ratio of the Employment to population ratio(%) of Libya in 1999 to that in 2003?
Your answer should be compact. 0.98. What is the ratio of the Employment to population ratio(%) of New Zealand in 1999 to that in 2003?
Give a very brief answer. 0.97. What is the ratio of the Employment to population ratio(%) of Zambia in 1999 to that in 2003?
Ensure brevity in your answer.  1.07. What is the ratio of the Employment to population ratio(%) in Afghanistan in 2000 to that in 2001?
Give a very brief answer. 1. What is the ratio of the Employment to population ratio(%) in New Zealand in 2000 to that in 2001?
Make the answer very short. 0.97. What is the ratio of the Employment to population ratio(%) in Zambia in 2000 to that in 2001?
Keep it short and to the point. 1.06. What is the ratio of the Employment to population ratio(%) in Libya in 2000 to that in 2002?
Your answer should be very brief. 0.98. What is the ratio of the Employment to population ratio(%) of New Zealand in 2000 to that in 2002?
Keep it short and to the point. 0.95. What is the ratio of the Employment to population ratio(%) of Zambia in 2000 to that in 2002?
Your answer should be very brief. 1.09. What is the ratio of the Employment to population ratio(%) in New Zealand in 2000 to that in 2003?
Provide a succinct answer. 0.96. What is the ratio of the Employment to population ratio(%) of Zambia in 2000 to that in 2003?
Ensure brevity in your answer.  1.05. What is the ratio of the Employment to population ratio(%) of Afghanistan in 2001 to that in 2002?
Your answer should be compact. 1. What is the ratio of the Employment to population ratio(%) of Libya in 2001 to that in 2002?
Your answer should be compact. 0.99. What is the ratio of the Employment to population ratio(%) in New Zealand in 2001 to that in 2002?
Ensure brevity in your answer.  0.99. What is the ratio of the Employment to population ratio(%) in Zambia in 2001 to that in 2002?
Offer a very short reply. 1.03. What is the ratio of the Employment to population ratio(%) of Afghanistan in 2001 to that in 2003?
Make the answer very short. 0.99. What is the ratio of the Employment to population ratio(%) in Zambia in 2001 to that in 2003?
Your response must be concise. 1. What is the ratio of the Employment to population ratio(%) in Afghanistan in 2002 to that in 2003?
Give a very brief answer. 0.99. What is the ratio of the Employment to population ratio(%) of Libya in 2002 to that in 2003?
Keep it short and to the point. 1. What is the ratio of the Employment to population ratio(%) in New Zealand in 2002 to that in 2003?
Ensure brevity in your answer.  1.01. What is the ratio of the Employment to population ratio(%) in Zambia in 2002 to that in 2003?
Provide a succinct answer. 0.97. What is the difference between the highest and the second highest Employment to population ratio(%) in Libya?
Keep it short and to the point. 0. What is the difference between the highest and the second highest Employment to population ratio(%) in New Zealand?
Offer a very short reply. 1.4. What is the difference between the highest and the lowest Employment to population ratio(%) of Afghanistan?
Your answer should be compact. 1.9. What is the difference between the highest and the lowest Employment to population ratio(%) in Libya?
Your answer should be compact. 0.9. What is the difference between the highest and the lowest Employment to population ratio(%) of New Zealand?
Offer a terse response. 5.4. What is the difference between the highest and the lowest Employment to population ratio(%) of Zambia?
Offer a terse response. 5.4. 